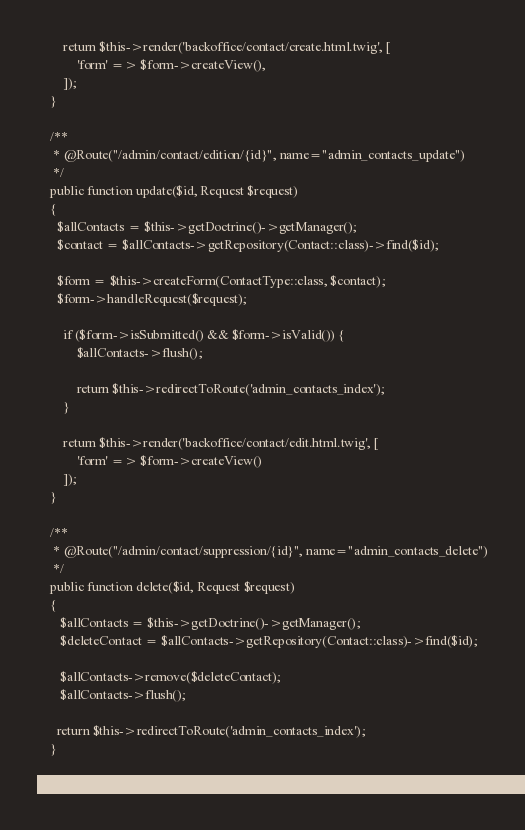<code> <loc_0><loc_0><loc_500><loc_500><_PHP_>
        return $this->render('backoffice/contact/create.html.twig', [
            'form' => $form->createView(),
        ]);
    }

    /**
     * @Route("/admin/contact/edition/{id}", name="admin_contacts_update")
     */
    public function update($id, Request $request)
    {
      $allContacts = $this->getDoctrine()->getManager();
      $contact = $allContacts->getRepository(Contact::class)->find($id);

      $form = $this->createForm(ContactType::class, $contact);
      $form->handleRequest($request);

        if ($form->isSubmitted() && $form->isValid()) {
            $allContacts->flush();

            return $this->redirectToRoute('admin_contacts_index');
        }

        return $this->render('backoffice/contact/edit.html.twig', [
            'form' => $form->createView()
        ]);
    }

    /**
     * @Route("/admin/contact/suppression/{id}", name="admin_contacts_delete")
     */
    public function delete($id, Request $request)
    {
       $allContacts = $this->getDoctrine()->getManager();
       $deleteContact = $allContacts->getRepository(Contact::class)->find($id);

       $allContacts->remove($deleteContact);
       $allContacts->flush();

      return $this->redirectToRoute('admin_contacts_index');
    }

    }
</code> 